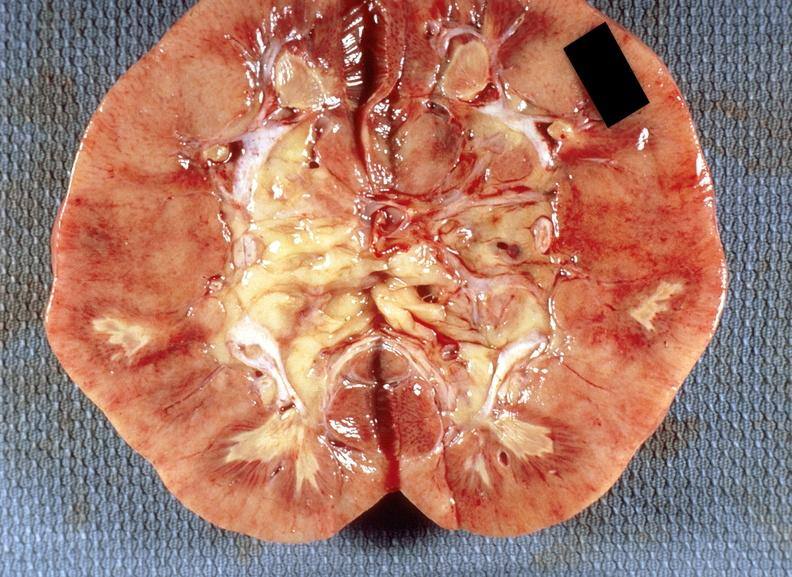what does this image show?
Answer the question using a single word or phrase. Kidney 